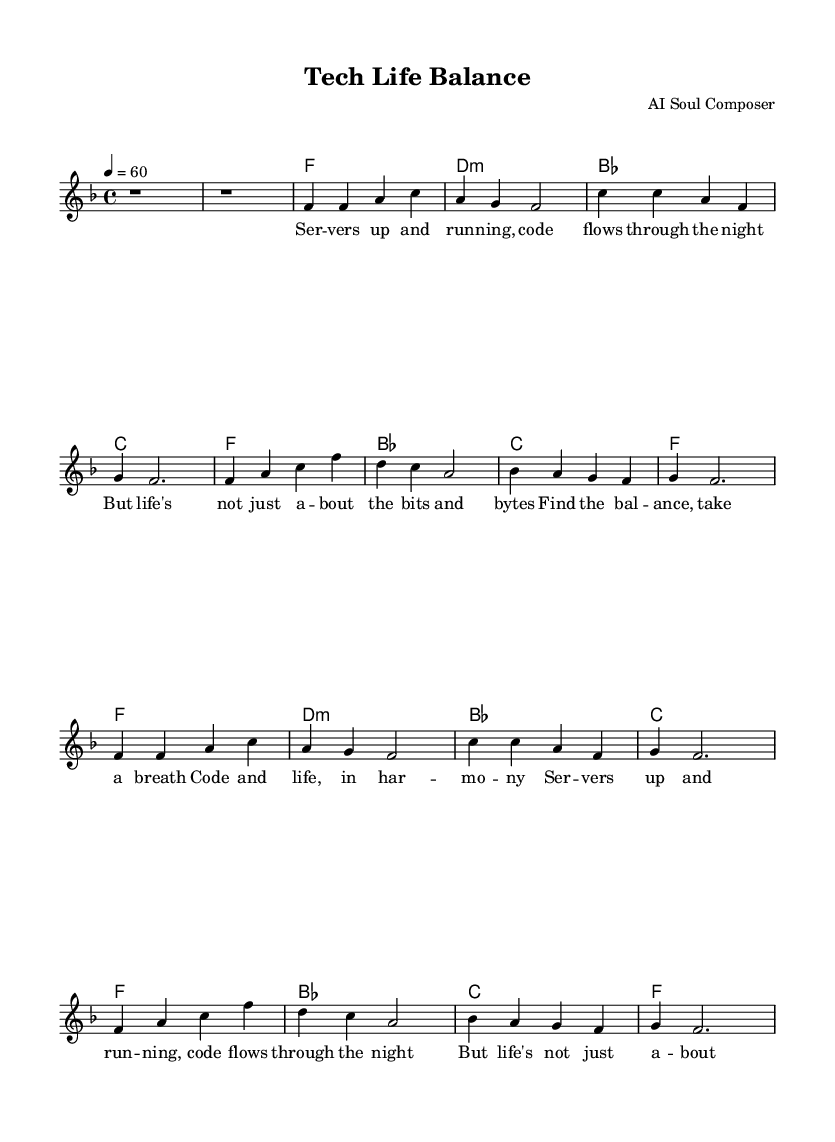What is the key signature of this music? The key signature is F major, which has one flat (B flat). This can be identified by looking at the beginning of the staff where the key signature is notated.
Answer: F major What is the time signature of this music? The time signature is 4/4, as seen at the beginning of the staff indicating that there are 4 beats in a measure and a quarter note gets one beat.
Answer: 4/4 What is the tempo marking of this music? The tempo marking is 60 beats per minute, indicated by the notation '4 = 60' above the staff, which tells the performer the speed of the piece.
Answer: 60 How many measures are in the verse section? The verse section consists of 4 measures, and counting each segment of notes separated by vertical lines confirms this count.
Answer: 4 What is the primary theme of the lyrics? The primary theme of the lyrics revolves around balancing work and life, which is evident from the phrases discussing coding and taking a breath, emphasizing the harmony needed in life amid work pressures.
Answer: Work-life balance Which chord is played during the chorus? The chord played during the chorus is B flat, as noted in the harmonies section of the sheet music, specifically listed in the chorus progression.
Answer: B flat 